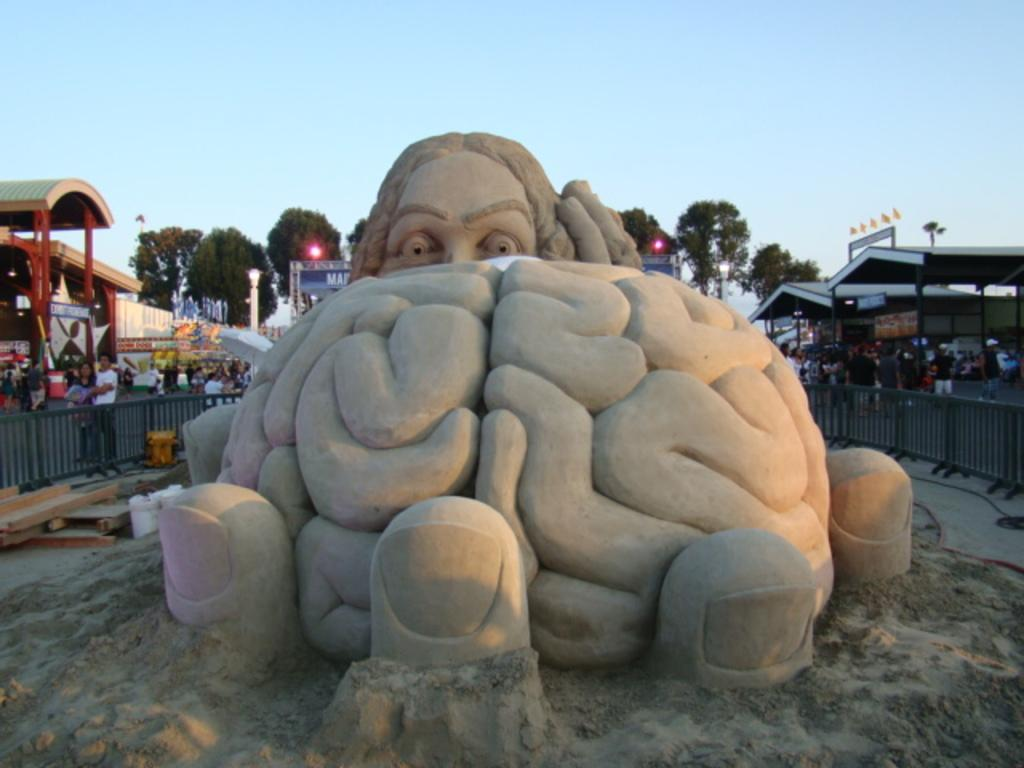What is the main subject of the image? The main subject of the image is a sand carving. What else can be seen in the image besides the sand carving? There is a fence, a group of people, boards, sheds, lights, poles, trees, and the sky visible in the background of the image. What type of silver material is used to create the sand carving in the image? There is no silver material used in the sand carving; it is made of sand. How do the birds navigate their way through the image? There are no birds present in the image. 